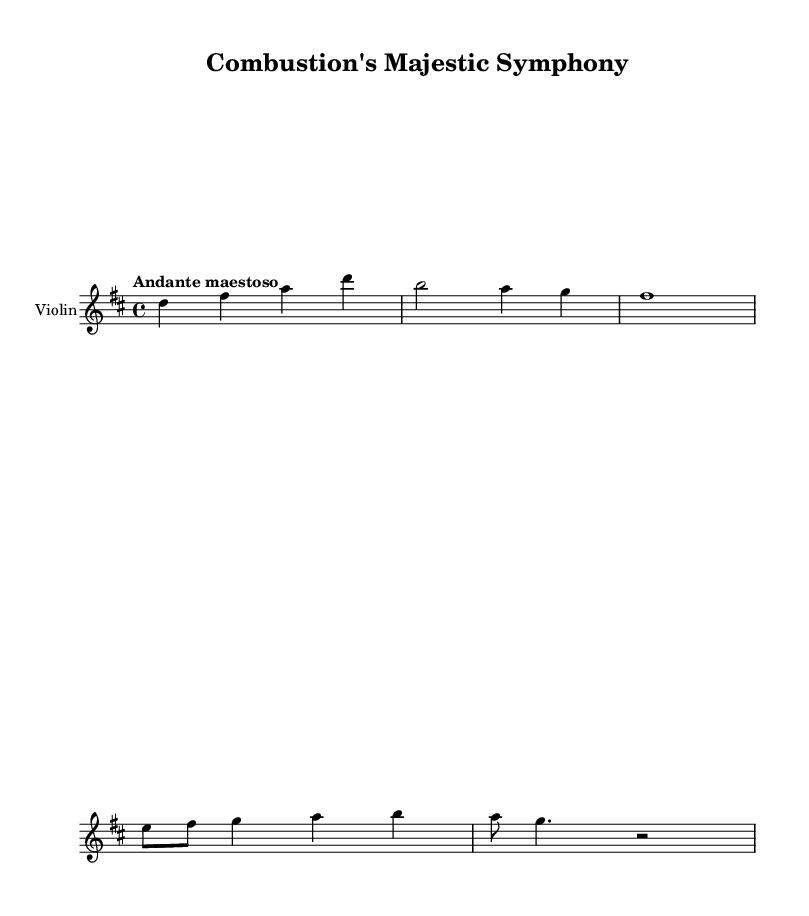What is the key signature of this music? The key signature is D major, which contains two sharps (F# and C#). This can be confirmed by looking at the key signature notation at the beginning of the score.
Answer: D major What is the time signature of this music? The time signature is 4/4, indicated by the notation at the beginning of the piece. This means there are four beats in each measure, and the quarter note gets one beat.
Answer: 4/4 What is the tempo marking for this piece? The tempo marking is "Andante maestoso," indicating a moderate walking pace characterized by a dignified and grand style. This marking is typically found at the start of the score.
Answer: Andante maestoso How many measures are present in the excerpt for the violin part? There are five measures in the excerpt provided for the violin part, which can be counted by looking at the vertical lines that separate each measure.
Answer: 5 Which note is the first note of the piece? The first note of the piece is a D, which is indicated on the staff. The note head appears on the fourth line of the treble staff, confirming its identity.
Answer: D What is the pattern of the notes in the first measure for the violin part? The first measure contains four notes: D, F#, A, and D. This can be verified by reading the notes shown in that measure from left to right.
Answer: D, F#, A, D What does the term "maestoso" indicate about the performance style? The term "maestoso" indicates that the performance should be dignified and majestic, adding a grandiose quality to the interpretation. This term is typically integrated into the tempo marking and conveys emotional richness.
Answer: Dignified 